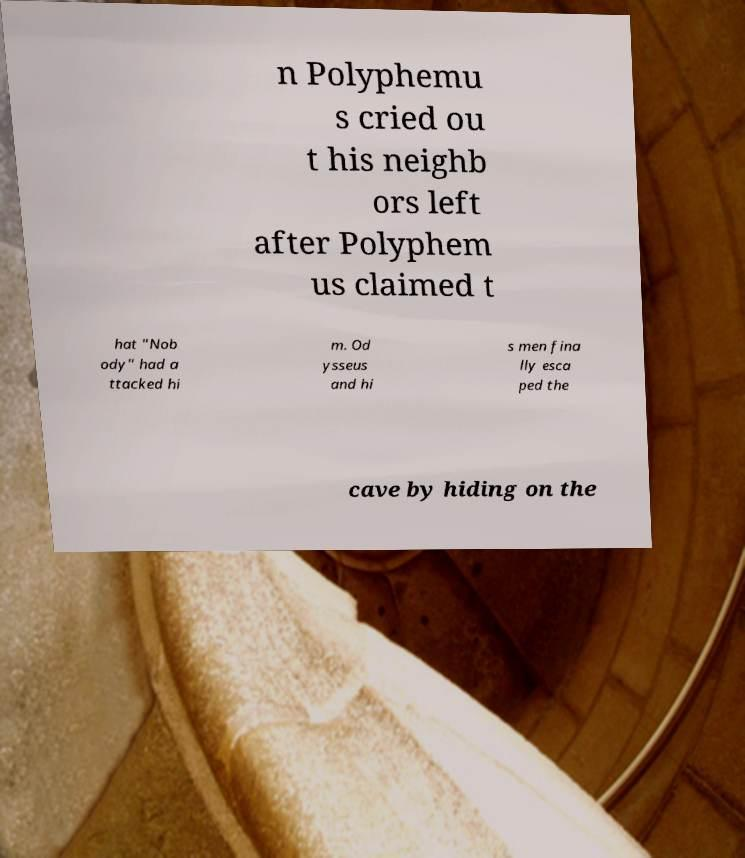What messages or text are displayed in this image? I need them in a readable, typed format. n Polyphemu s cried ou t his neighb ors left after Polyphem us claimed t hat "Nob ody" had a ttacked hi m. Od ysseus and hi s men fina lly esca ped the cave by hiding on the 